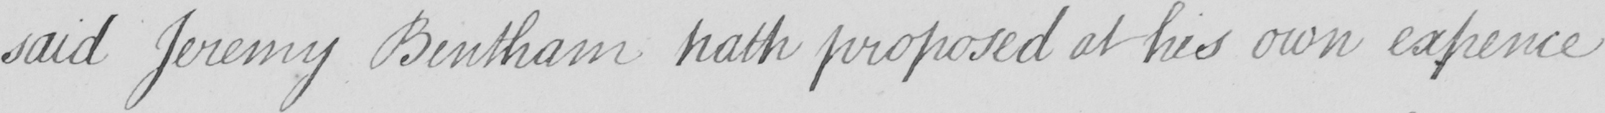Please transcribe the handwritten text in this image. said Jeremy Bentham hath proposed at his own expence 